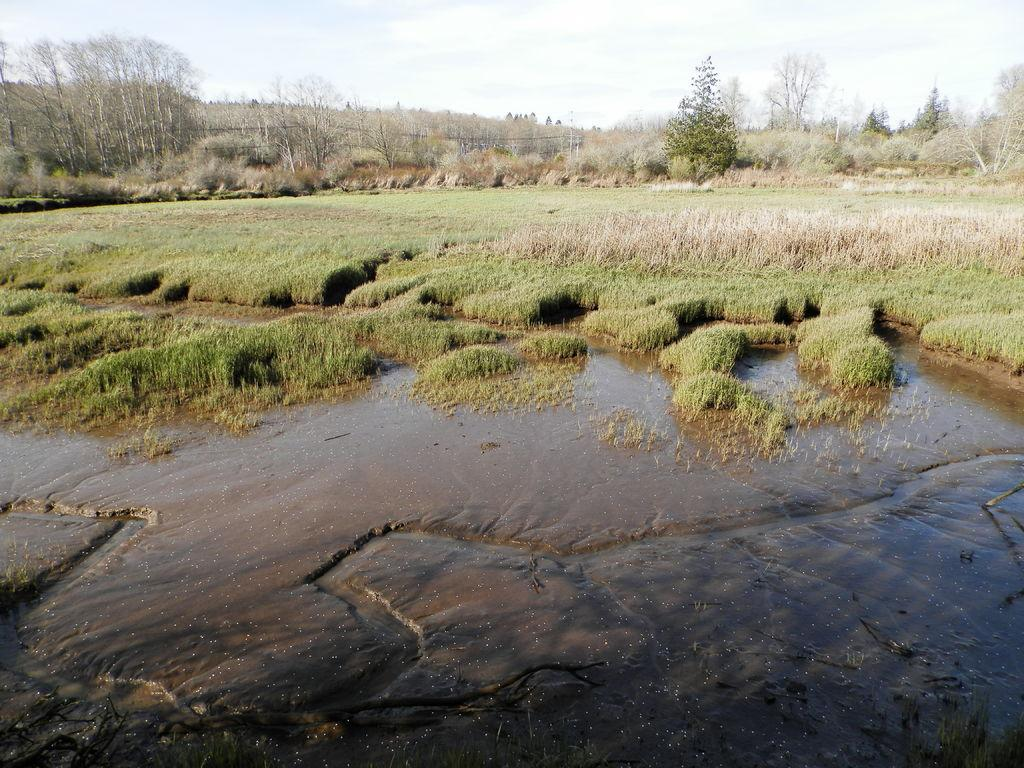What type of vegetation can be seen in the image? There are trees in the image. What is visible beneath the trees? The ground is visible in the image. What natural element is present in addition to the trees and ground? There is water visible in the image. What is the condition of the sky in the image? The sky is cloudy in the image. What type of window can be seen in the image? There is no window present in the image; it features trees, ground, water, and a cloudy sky. How many crates are stacked on top of each other in the image? There are no crates present in the image. 